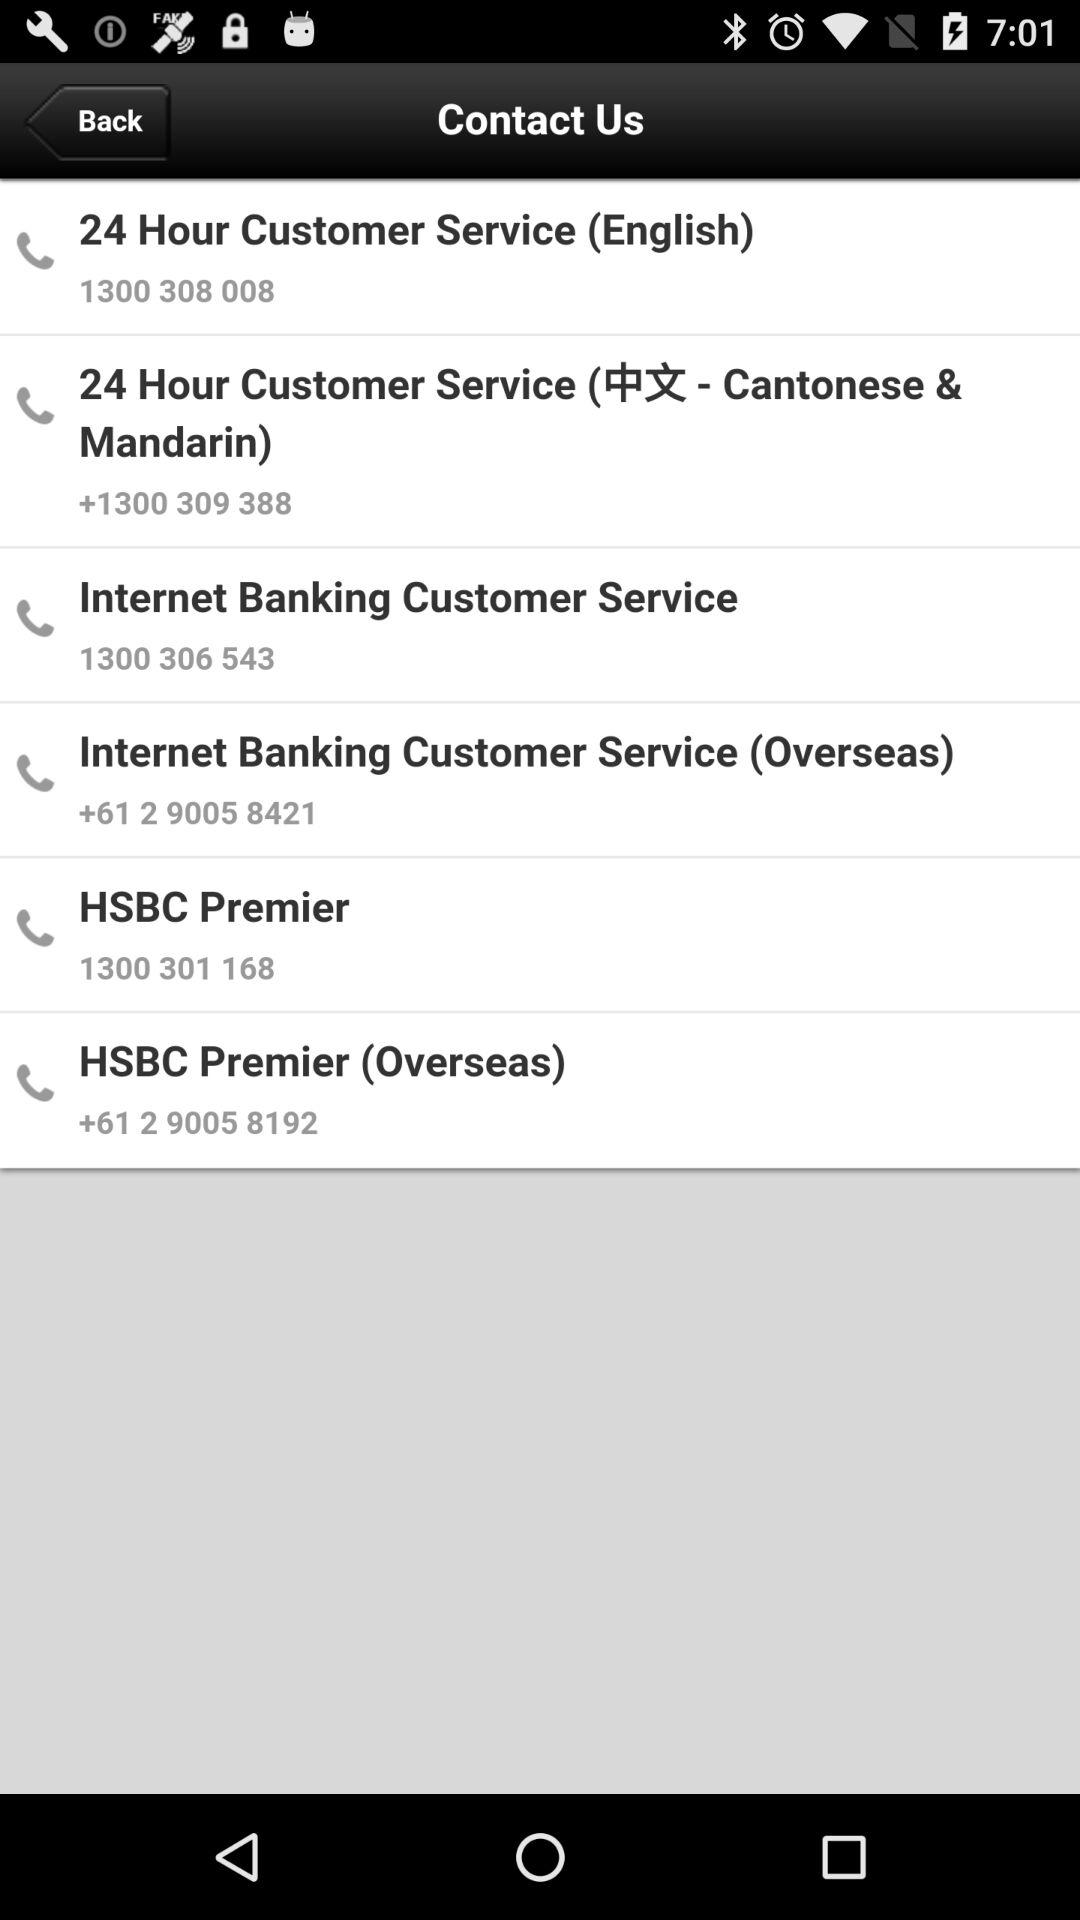How many contact numbers are there for 24 Hour Customer Service?
Answer the question using a single word or phrase. 2 